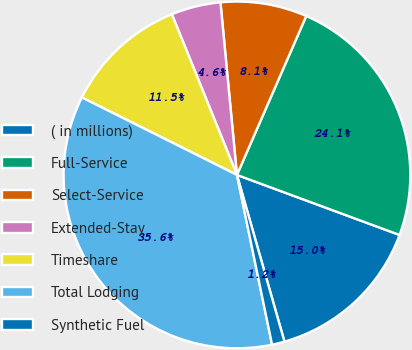Convert chart to OTSL. <chart><loc_0><loc_0><loc_500><loc_500><pie_chart><fcel>( in millions)<fcel>Full-Service<fcel>Select-Service<fcel>Extended-Stay<fcel>Timeshare<fcel>Total Lodging<fcel>Synthetic Fuel<nl><fcel>14.95%<fcel>24.08%<fcel>8.06%<fcel>4.61%<fcel>11.5%<fcel>35.62%<fcel>1.17%<nl></chart> 